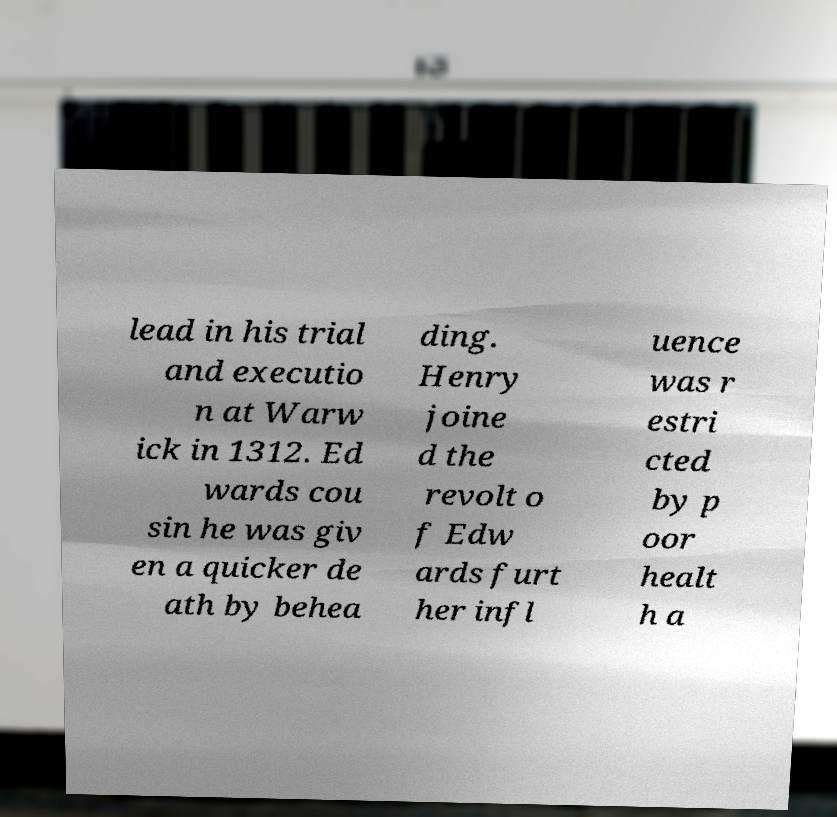For documentation purposes, I need the text within this image transcribed. Could you provide that? lead in his trial and executio n at Warw ick in 1312. Ed wards cou sin he was giv en a quicker de ath by behea ding. Henry joine d the revolt o f Edw ards furt her infl uence was r estri cted by p oor healt h a 